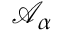Convert formula to latex. <formula><loc_0><loc_0><loc_500><loc_500>\mathcal { A } _ { \alpha }</formula> 